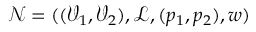Convert formula to latex. <formula><loc_0><loc_0><loc_500><loc_500>\mathcal { N } = ( ( \mathcal { V } _ { 1 } , \mathcal { V } _ { 2 } ) , \mathcal { L } , ( p _ { 1 } , p _ { 2 } ) , w )</formula> 